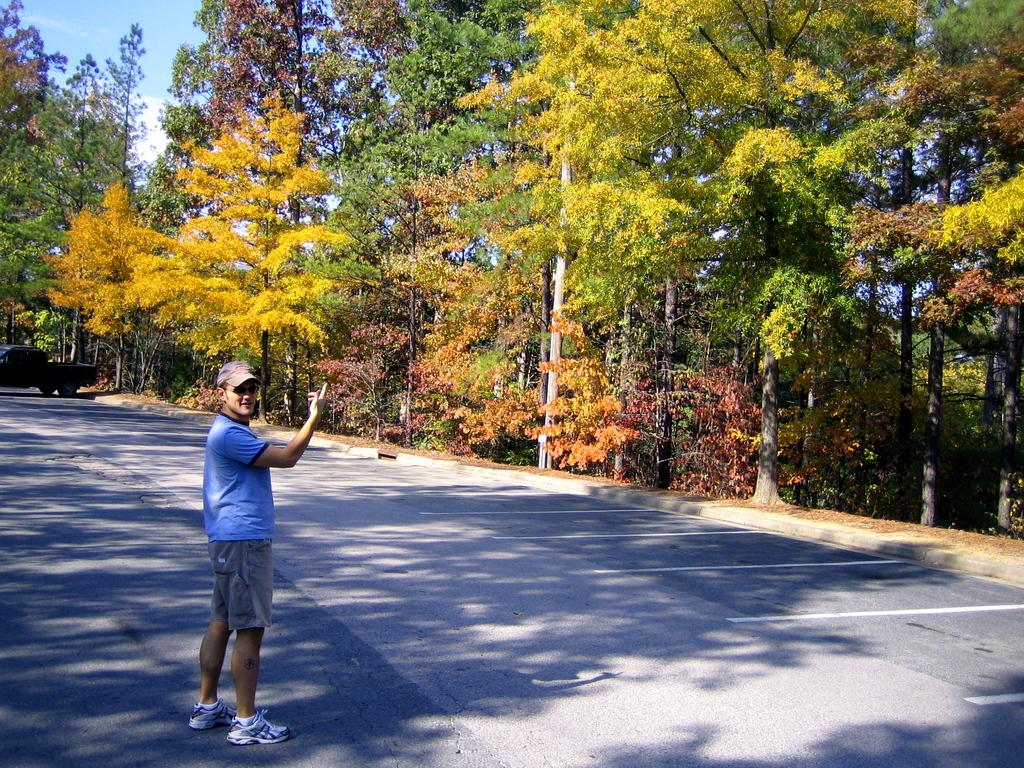Who is present in the image? There is a person in the image. What is the person wearing? The person is wearing a blue T-shirt. Where is the person located in the image? The person is standing on the road. What else can be seen in the image? There is a vehicle in the left corner of the image, and there are trees in the background. What type of oil is being used by the person in the image? There is no indication of oil being used in the image; the person is simply standing on the road. 